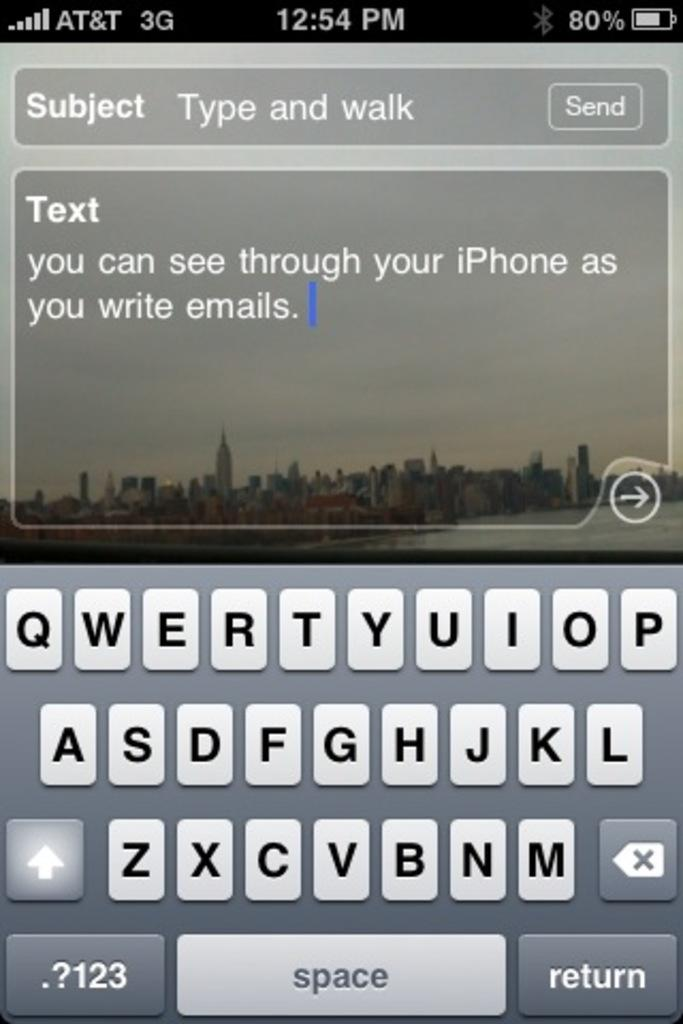Provide a one-sentence caption for the provided image. A phone screen of a text that says you can see through your iPhone. 